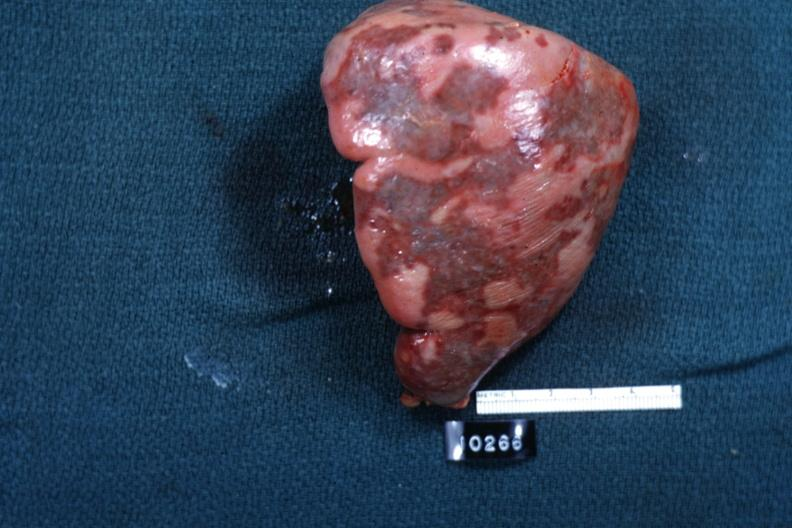s external view of spleen with multiple recent infarcts cut surface is slide?
Answer the question using a single word or phrase. Yes 